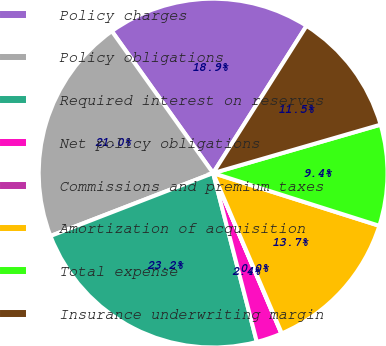Convert chart to OTSL. <chart><loc_0><loc_0><loc_500><loc_500><pie_chart><fcel>Policy charges<fcel>Policy obligations<fcel>Required interest on reserves<fcel>Net policy obligations<fcel>Commissions and premium taxes<fcel>Amortization of acquisition<fcel>Total expense<fcel>Insurance underwriting margin<nl><fcel>18.86%<fcel>21.01%<fcel>23.16%<fcel>2.37%<fcel>0.04%<fcel>13.67%<fcel>9.37%<fcel>11.52%<nl></chart> 